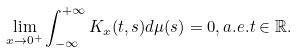<formula> <loc_0><loc_0><loc_500><loc_500>\lim _ { x \rightarrow 0 ^ { + } } \int _ { - \infty } ^ { + \infty } K _ { x } ( t , s ) d \mu ( s ) = 0 , a . e . t \in \mathbb { R } .</formula> 